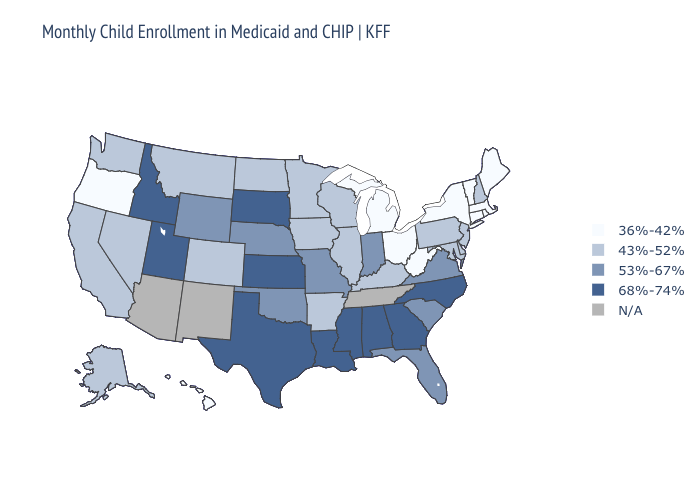What is the value of Hawaii?
Short answer required. 36%-42%. Among the states that border Wyoming , which have the highest value?
Concise answer only. Idaho, South Dakota, Utah. What is the lowest value in the South?
Keep it brief. 36%-42%. Does Maine have the lowest value in the Northeast?
Quick response, please. Yes. Name the states that have a value in the range 68%-74%?
Quick response, please. Alabama, Georgia, Idaho, Kansas, Louisiana, Mississippi, North Carolina, South Dakota, Texas, Utah. What is the value of New York?
Answer briefly. 36%-42%. Among the states that border Montana , which have the highest value?
Keep it brief. Idaho, South Dakota. Among the states that border Ohio , which have the highest value?
Give a very brief answer. Indiana. Among the states that border Washington , does Oregon have the highest value?
Be succinct. No. Which states have the lowest value in the South?
Keep it brief. West Virginia. What is the value of Maine?
Quick response, please. 36%-42%. Name the states that have a value in the range N/A?
Give a very brief answer. Arizona, New Mexico, Tennessee. Name the states that have a value in the range 36%-42%?
Keep it brief. Connecticut, Hawaii, Maine, Massachusetts, Michigan, New York, Ohio, Oregon, Rhode Island, Vermont, West Virginia. Which states hav the highest value in the MidWest?
Be succinct. Kansas, South Dakota. 